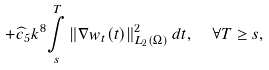Convert formula to latex. <formula><loc_0><loc_0><loc_500><loc_500>+ \widehat { c } _ { 5 } k ^ { 8 } \underset { s } { \overset { T } { \int } } \left \| \nabla w _ { t } ( t ) \right \| _ { L _ { 2 } ( \Omega ) } ^ { 2 } d t , \text { \ } \forall T \geq s ,</formula> 